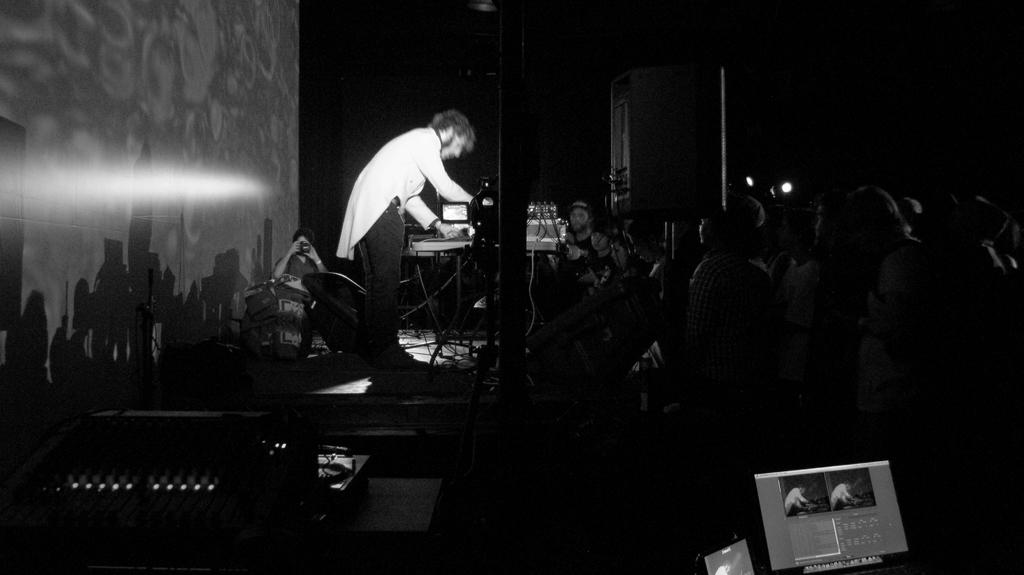What is the color scheme of the image? The image is black and white. Where are most of the people located in the image? There are many people on the right side of the image. What can be seen in the middle of the image? There is a man in the middle of the image, and there are musical instruments present. What is the man doing in the image? The man is playing something in the middle of the image. What type of apparel is the moon wearing in the image? There is no moon present in the image, and therefore no apparel can be associated with it. How does the ice affect the people's activities in the image? There is no ice present in the image, so it does not affect the people's activities. 